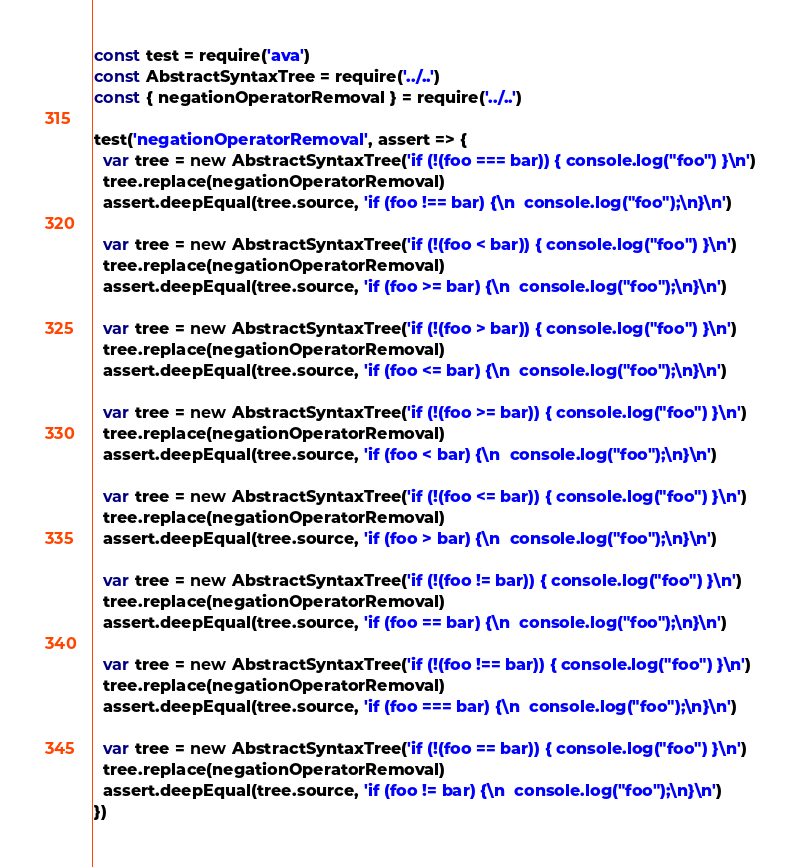<code> <loc_0><loc_0><loc_500><loc_500><_JavaScript_>const test = require('ava')
const AbstractSyntaxTree = require('../..')
const { negationOperatorRemoval } = require('../..')

test('negationOperatorRemoval', assert => {
  var tree = new AbstractSyntaxTree('if (!(foo === bar)) { console.log("foo") }\n')
  tree.replace(negationOperatorRemoval)
  assert.deepEqual(tree.source, 'if (foo !== bar) {\n  console.log("foo");\n}\n')

  var tree = new AbstractSyntaxTree('if (!(foo < bar)) { console.log("foo") }\n')
  tree.replace(negationOperatorRemoval)
  assert.deepEqual(tree.source, 'if (foo >= bar) {\n  console.log("foo");\n}\n')

  var tree = new AbstractSyntaxTree('if (!(foo > bar)) { console.log("foo") }\n')
  tree.replace(negationOperatorRemoval)
  assert.deepEqual(tree.source, 'if (foo <= bar) {\n  console.log("foo");\n}\n')

  var tree = new AbstractSyntaxTree('if (!(foo >= bar)) { console.log("foo") }\n')
  tree.replace(negationOperatorRemoval)
  assert.deepEqual(tree.source, 'if (foo < bar) {\n  console.log("foo");\n}\n')

  var tree = new AbstractSyntaxTree('if (!(foo <= bar)) { console.log("foo") }\n')
  tree.replace(negationOperatorRemoval)
  assert.deepEqual(tree.source, 'if (foo > bar) {\n  console.log("foo");\n}\n')

  var tree = new AbstractSyntaxTree('if (!(foo != bar)) { console.log("foo") }\n')
  tree.replace(negationOperatorRemoval)
  assert.deepEqual(tree.source, 'if (foo == bar) {\n  console.log("foo");\n}\n')

  var tree = new AbstractSyntaxTree('if (!(foo !== bar)) { console.log("foo") }\n')
  tree.replace(negationOperatorRemoval)
  assert.deepEqual(tree.source, 'if (foo === bar) {\n  console.log("foo");\n}\n')

  var tree = new AbstractSyntaxTree('if (!(foo == bar)) { console.log("foo") }\n')
  tree.replace(negationOperatorRemoval)
  assert.deepEqual(tree.source, 'if (foo != bar) {\n  console.log("foo");\n}\n')
})
</code> 